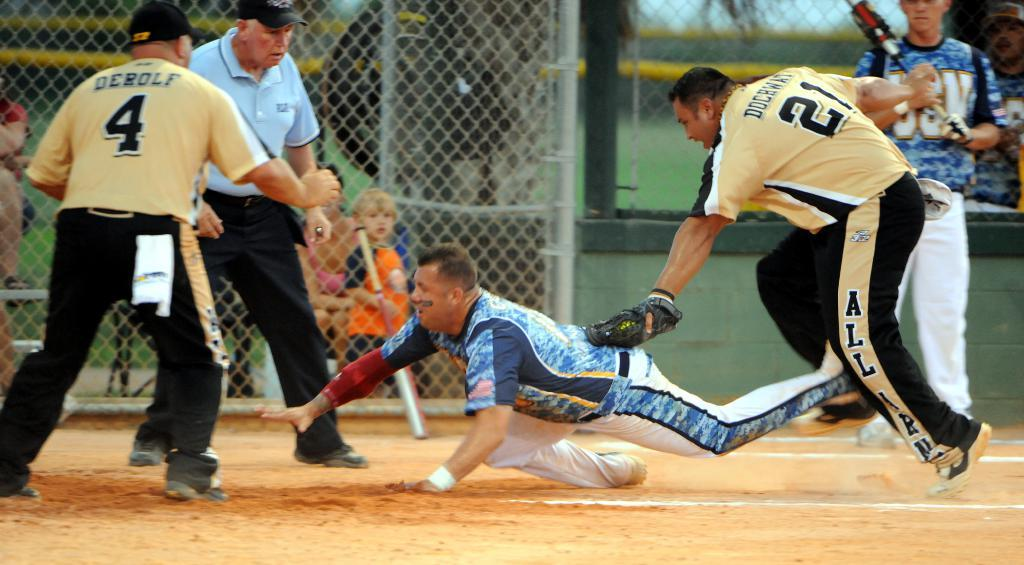<image>
Write a terse but informative summary of the picture. A player from the blue team slides into base as player 21 and player 4 try to tag him out. 